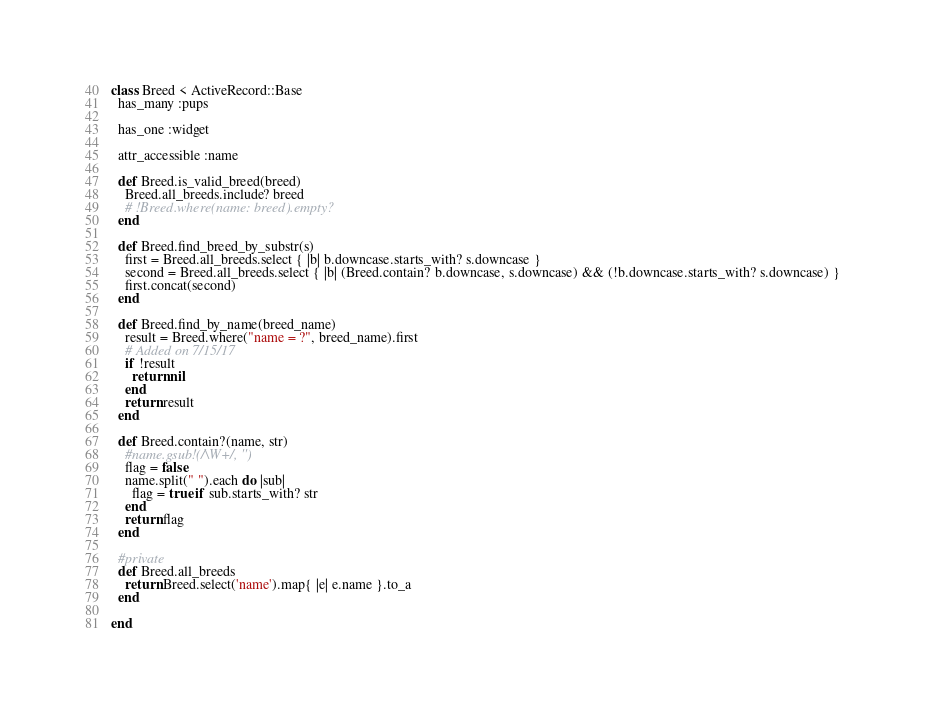Convert code to text. <code><loc_0><loc_0><loc_500><loc_500><_Ruby_>class Breed < ActiveRecord::Base
  has_many :pups
  
  has_one :widget
  
  attr_accessible :name

  def Breed.is_valid_breed(breed)
    Breed.all_breeds.include? breed
    # !Breed.where(name: breed).empty?
  end

  def Breed.find_breed_by_substr(s)
    first = Breed.all_breeds.select { |b| b.downcase.starts_with? s.downcase }
    second = Breed.all_breeds.select { |b| (Breed.contain? b.downcase, s.downcase) && (!b.downcase.starts_with? s.downcase) }
    first.concat(second)
  end

  def Breed.find_by_name(breed_name)
    result = Breed.where("name = ?", breed_name).first
    # Added on 7/15/17
    if !result
      return nil
    end
    return result
  end
  
  def Breed.contain?(name, str)
    #name.gsub!(/\W+/, '')
    flag = false
    name.split(" ").each do |sub|
      flag = true if sub.starts_with? str
    end
    return flag
  end

  #private
  def Breed.all_breeds
    return Breed.select('name').map{ |e| e.name }.to_a
  end

end
</code> 